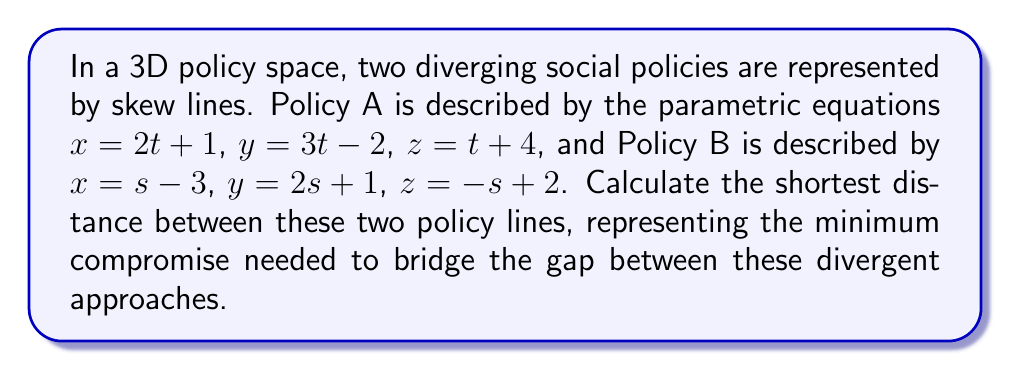Could you help me with this problem? To find the shortest distance between two skew lines in 3D space, we'll follow these steps:

1) First, we need to find the direction vectors of both lines:
   For Policy A: $\vec{a} = (2, 3, 1)$
   For Policy B: $\vec{b} = (1, 2, -1)$

2) Calculate the cross product of these direction vectors:
   $\vec{n} = \vec{a} \times \vec{b} = (2, 3, 1) \times (1, 2, -1)$
   $= (3(-1) - 1(2), 1(1) - 2(-1), 2(2) - 3(1))$
   $= (-3 - 2, 1 + 2, 4 - 3)$
   $= (-5, 3, 1)$

3) Normalize this vector:
   $|\vec{n}| = \sqrt{(-5)^2 + 3^2 + 1^2} = \sqrt{35}$
   $\hat{n} = \frac{\vec{n}}{|\vec{n}|} = \frac{1}{\sqrt{35}}(-5, 3, 1)$

4) Find a point on each line:
   For Policy A (t = 0): $P_1 = (1, -2, 4)$
   For Policy B (s = 0): $P_2 = (-3, 1, 2)$

5) Calculate the vector between these points:
   $\vec{P_1P_2} = P_2 - P_1 = (-3, 1, 2) - (1, -2, 4) = (-4, 3, -2)$

6) The shortest distance is the absolute value of the dot product of this vector with our normalized cross product:
   $d = |\vec{P_1P_2} \cdot \hat{n}|$
   $= |(-4, 3, -2) \cdot \frac{1}{\sqrt{35}}(-5, 3, 1)|$
   $= |\frac{1}{\sqrt{35}}(20 + 9 - 2)|$
   $= \frac{27}{\sqrt{35}}$

This distance represents the minimum "policy gap" between the two divergent approaches, quantifying the least amount of compromise needed to bridge their differences.
Answer: $$\frac{27}{\sqrt{35}} \approx 4.56$$ 